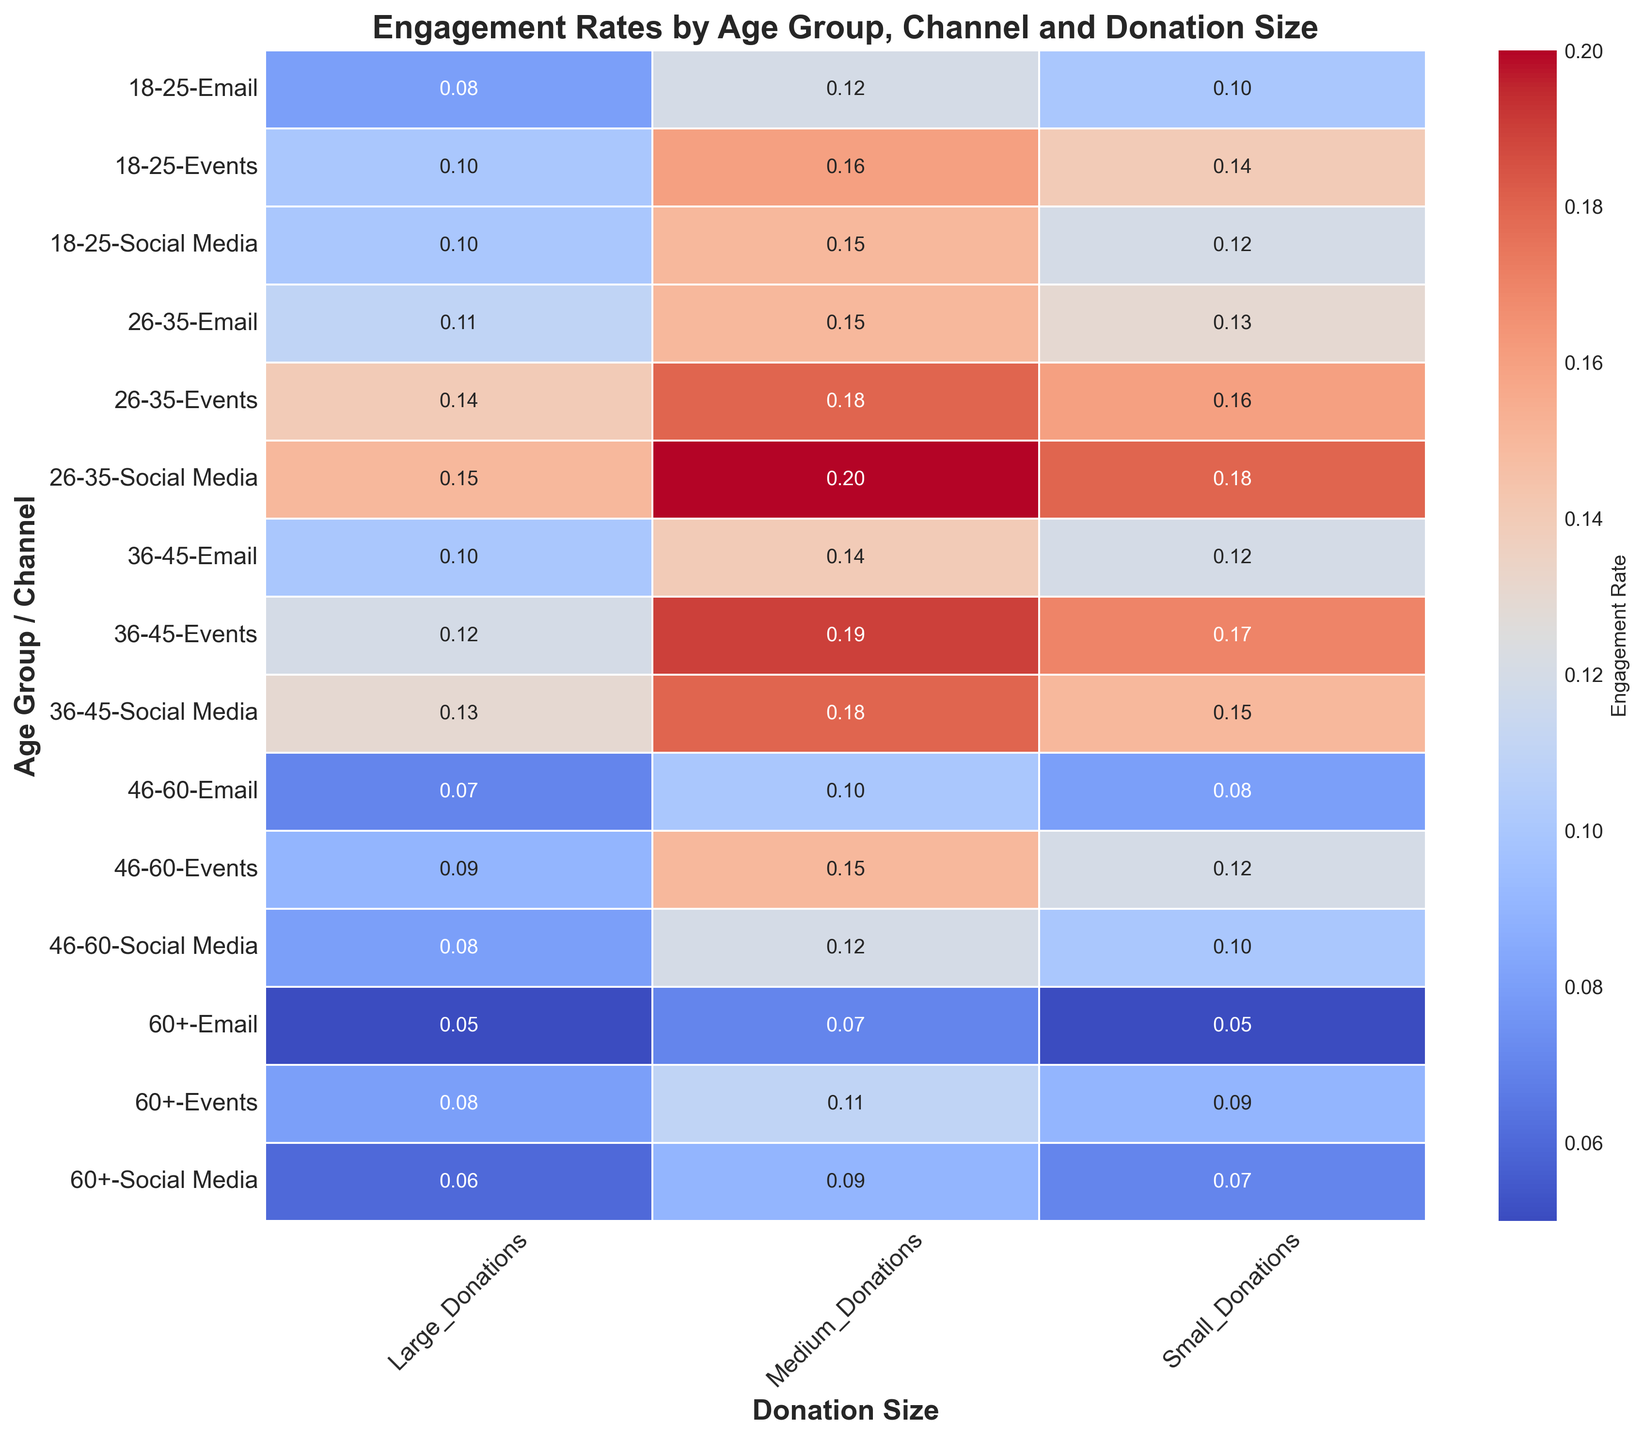What age group has the highest engagement rate for social media for medium donations? Look for the highest value in the rows under 'Social Media' for medium donations. The highest value for medium donations is 0.20 for the 26-35 age group.
Answer: 26-35 Which age group/channel combination has the lowest engagement rate for small donations? Compare engagement rates for all age group/channel combinations under small donations. The lowest value is 0.05 for the 60+ age group via Email.
Answer: 60+ / Email Between the age groups 18-25 and 26-35, which has a higher average engagement rate across all donation sizes for events? Calculate the average for the two age groups for events. For 18-25: (0.14 + 0.16 + 0.10)/3 = 0.1333. For 26-35: (0.16 + 0.18 + 0.14)/3 = 0.16. 26-35 is higher.
Answer: 26-35 What is the difference in engagement rates for large donations between the 36-45 age group using social media and email? Look up the large donation engagement rates for 36-45 via social media (0.13) and email (0.10) and subtract: 0.13 - 0.10 = 0.03.
Answer: 0.03 How does the engagement rate for small donations for the age group 46-60 compare between social media and events? Locate the small donation rates for 46-60: Social Media is 0.10, Events is 0.12. Events have a higher rate than Social Media by 0.02.
Answer: Events higher by 0.02 Is the engagement rate for medium donations higher in email or social media for the 18-25 age group? Get the medium donation rates for 18-25: Social Media is 0.15, and Email is 0.12. Social Media has a higher rate.
Answer: Social Media What visual pattern do you notice for engagement rates for small donations? Observe the color intensity for small donations column. Generally, engagement rates decrease with age; highest in 26-35 group, lowest in 60+ group.
Answer: Decrease with age Calculate the summed engagement rates for the 26-35 age group across all channels and donation sizes. Add engagement rates for all channels in 26-35: (0.18+0.20+0.15) + (0.13+0.15+0.11) + (0.16+0.18+0.14) = 0.53 + 0.39 + 0.48 = 1.40.
Answer: 1.40 